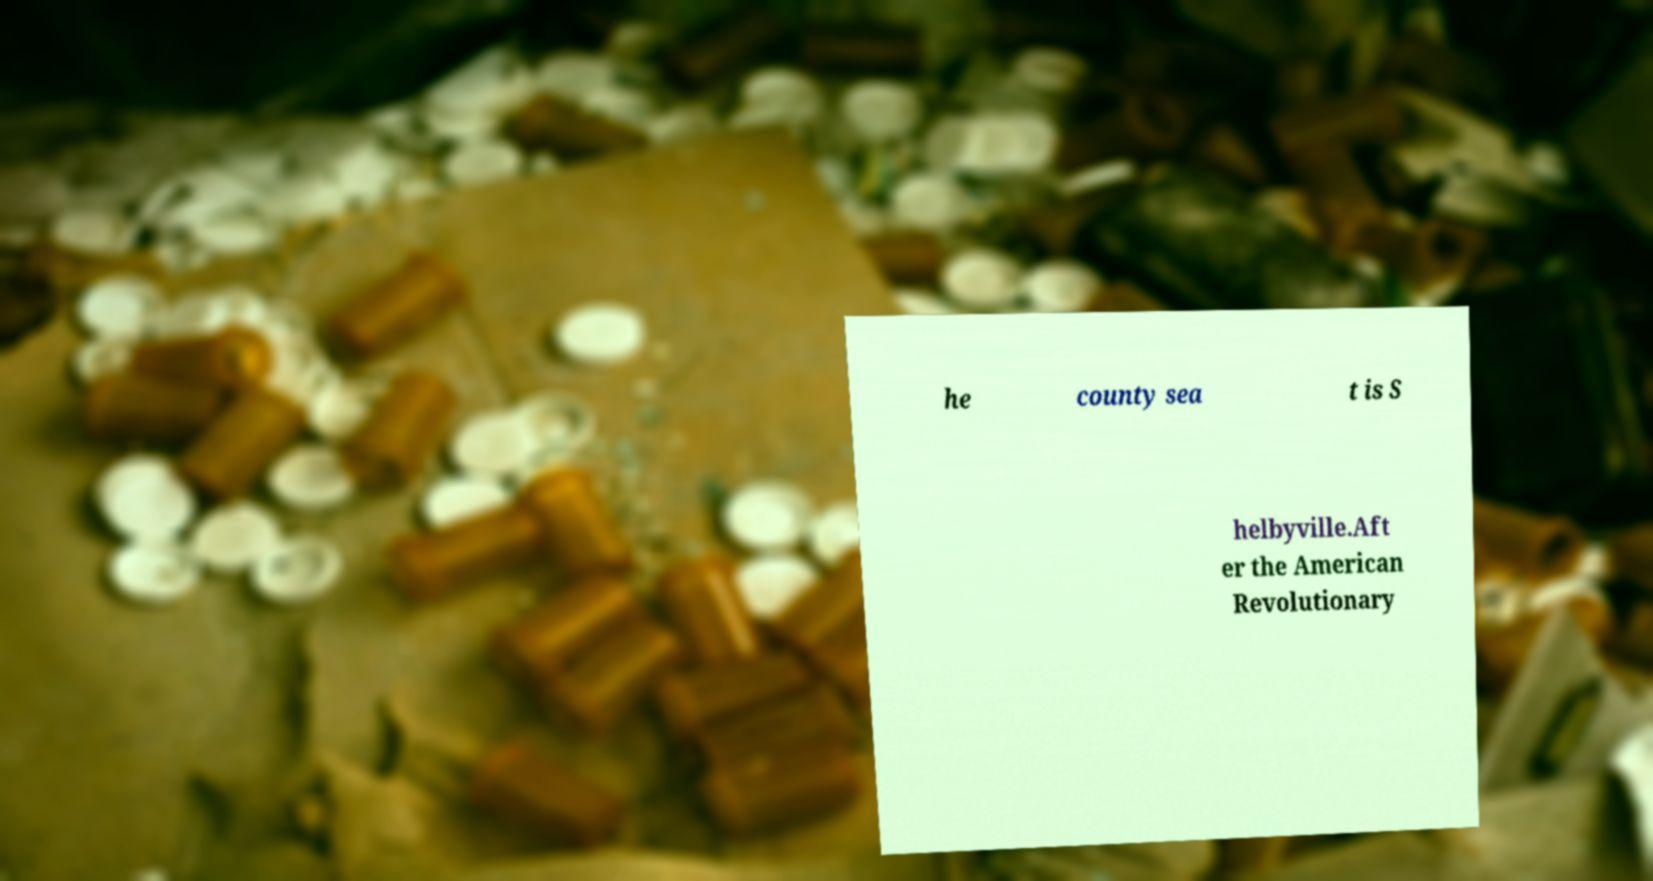Please read and relay the text visible in this image. What does it say? he county sea t is S helbyville.Aft er the American Revolutionary 